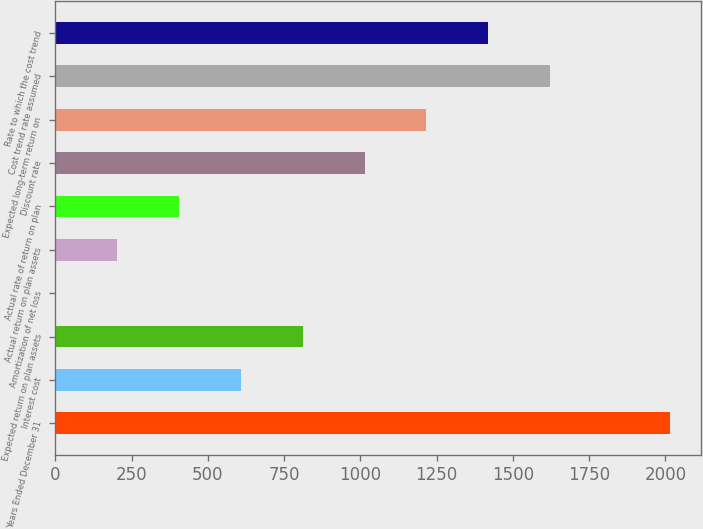Convert chart. <chart><loc_0><loc_0><loc_500><loc_500><bar_chart><fcel>Years Ended December 31<fcel>Interest cost<fcel>Expected return on plan assets<fcel>Amortization of net loss<fcel>Actual return on plan assets<fcel>Actual rate of return on plan<fcel>Discount rate<fcel>Expected long-term return on<fcel>Cost trend rate assumed<fcel>Rate to which the cost trend<nl><fcel>2016<fcel>608.8<fcel>811.4<fcel>1<fcel>203.6<fcel>406.2<fcel>1014<fcel>1216.6<fcel>1621.8<fcel>1419.2<nl></chart> 